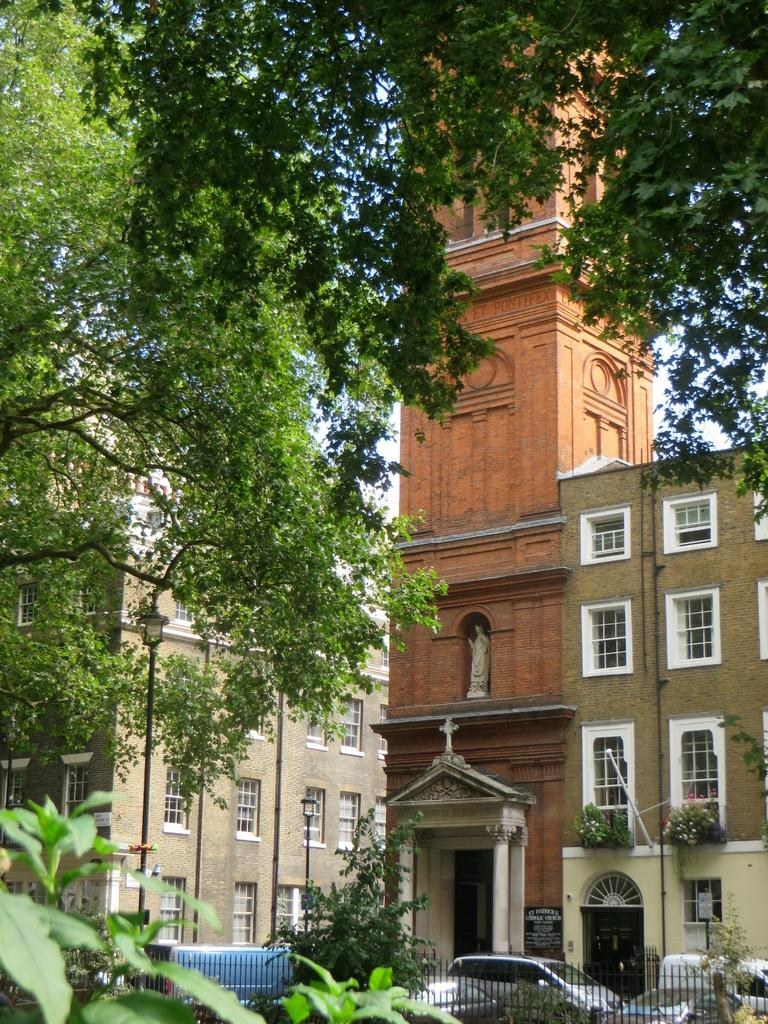What type of vehicles can be seen in the image? There are cars in the image. What is the barrier that separates the cars from the rest of the scene? There is a fence in the image. What type of vegetation is present in the image? There are plants and trees in the image. What are the tall, thin structures in the image? There are poles in the image. What type of structures can be seen in the background of the image? There are buildings in the image. What is visible in the background of the image? The sky is visible in the background of the image. Where is the table located in the image? There is no table present in the image. What type of fan can be seen in the image? There is no fan present in the image. 